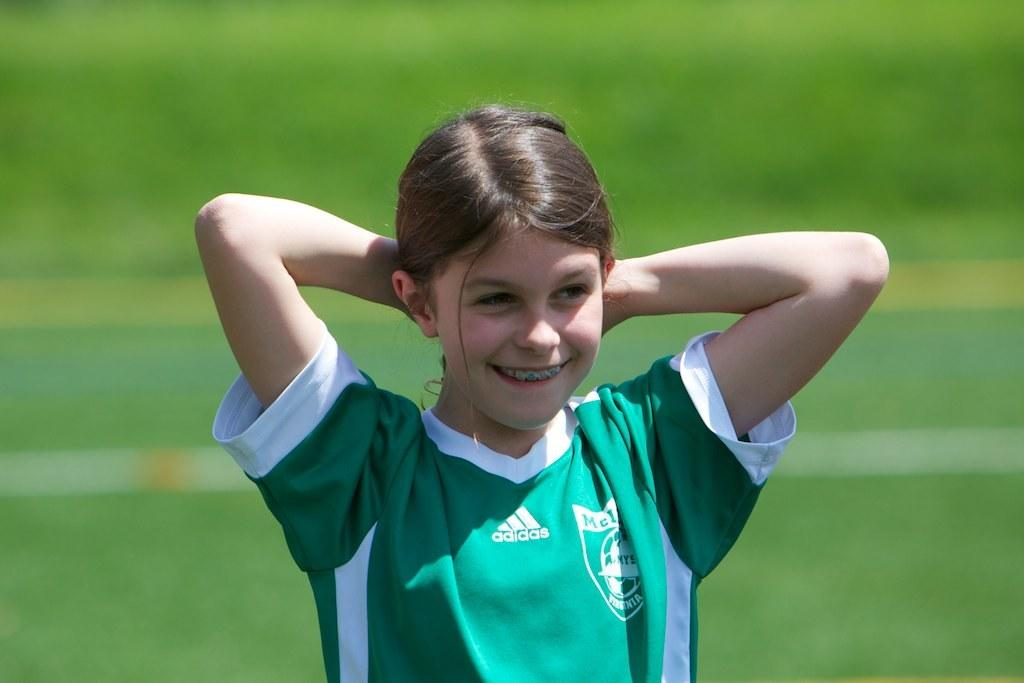<image>
Write a terse but informative summary of the picture. A young girl in braces wears an Adidas uniform. 